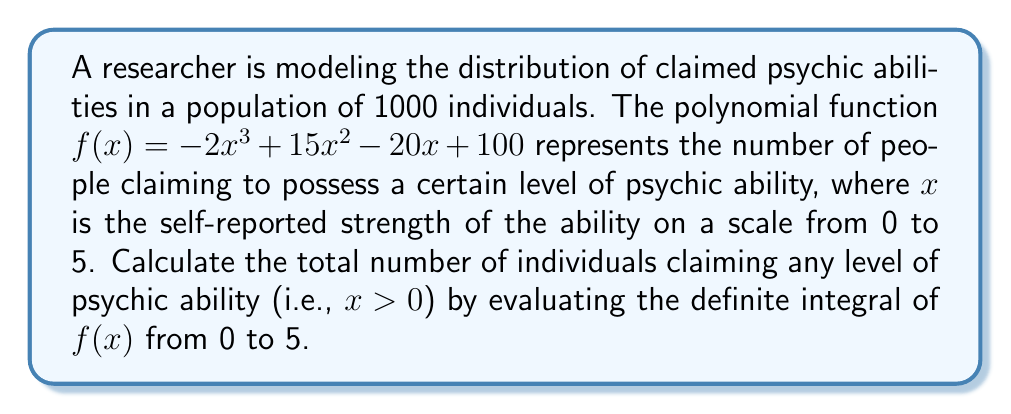Can you answer this question? To solve this problem, we need to follow these steps:

1) The definite integral of $f(x)$ from 0 to 5 will give us the area under the curve, which represents the total number of individuals claiming psychic abilities.

2) The integral of $f(x) = -2x^3 + 15x^2 - 20x + 100$ is:

   $F(x) = -\frac{1}{2}x^4 + 5x^3 - 10x^2 + 100x + C$

3) We need to evaluate $F(5) - F(0)$:

   $F(5) = -\frac{1}{2}(5^4) + 5(5^3) - 10(5^2) + 100(5)$
         $= -312.5 + 625 - 250 + 500 = 562.5$

   $F(0) = 0$

4) Therefore, the definite integral is:

   $\int_0^5 f(x) dx = F(5) - F(0) = 562.5 - 0 = 562.5$

5) Since we're dealing with whole numbers of people, we round this to 563.

This result indicates that out of the 1000 individuals in the population, 563 claim to have some level of psychic ability.
Answer: 563 individuals 